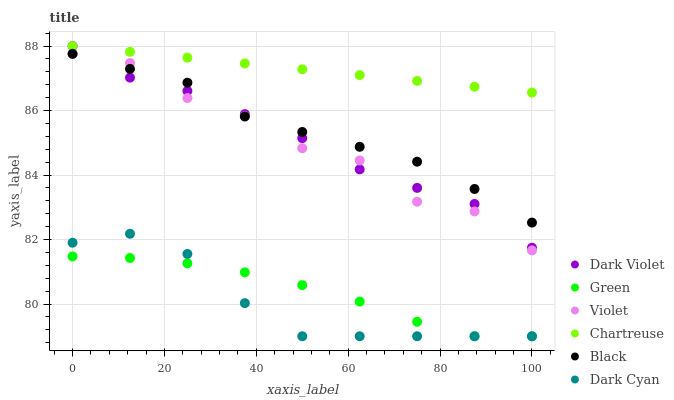Does Dark Cyan have the minimum area under the curve?
Answer yes or no. Yes. Does Chartreuse have the maximum area under the curve?
Answer yes or no. Yes. Does Black have the minimum area under the curve?
Answer yes or no. No. Does Black have the maximum area under the curve?
Answer yes or no. No. Is Chartreuse the smoothest?
Answer yes or no. Yes. Is Violet the roughest?
Answer yes or no. Yes. Is Black the smoothest?
Answer yes or no. No. Is Black the roughest?
Answer yes or no. No. Does Dark Cyan have the lowest value?
Answer yes or no. Yes. Does Black have the lowest value?
Answer yes or no. No. Does Chartreuse have the highest value?
Answer yes or no. Yes. Does Black have the highest value?
Answer yes or no. No. Is Dark Cyan less than Dark Violet?
Answer yes or no. Yes. Is Chartreuse greater than Dark Cyan?
Answer yes or no. Yes. Does Chartreuse intersect Dark Violet?
Answer yes or no. Yes. Is Chartreuse less than Dark Violet?
Answer yes or no. No. Is Chartreuse greater than Dark Violet?
Answer yes or no. No. Does Dark Cyan intersect Dark Violet?
Answer yes or no. No. 